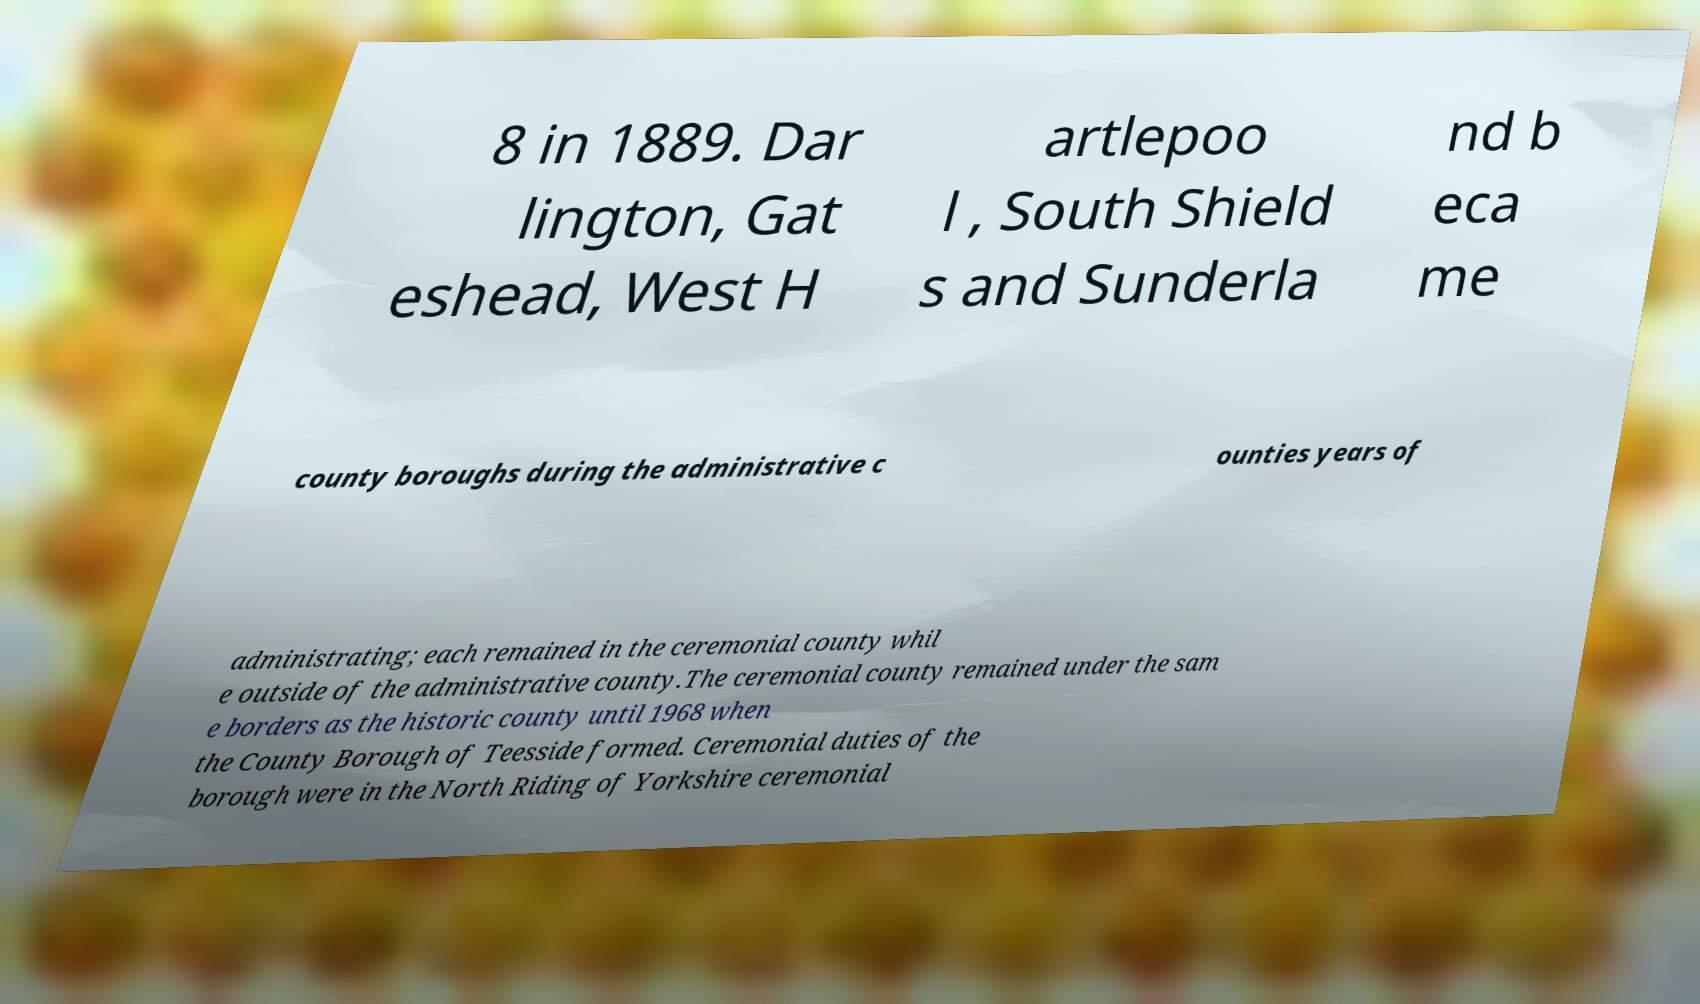Please identify and transcribe the text found in this image. 8 in 1889. Dar lington, Gat eshead, West H artlepoo l , South Shield s and Sunderla nd b eca me county boroughs during the administrative c ounties years of administrating; each remained in the ceremonial county whil e outside of the administrative county.The ceremonial county remained under the sam e borders as the historic county until 1968 when the County Borough of Teesside formed. Ceremonial duties of the borough were in the North Riding of Yorkshire ceremonial 